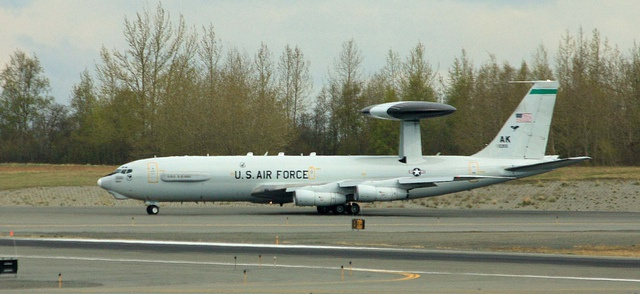Describe the objects in this image and their specific colors. I can see a airplane in lightgray, darkgray, gray, and black tones in this image. 